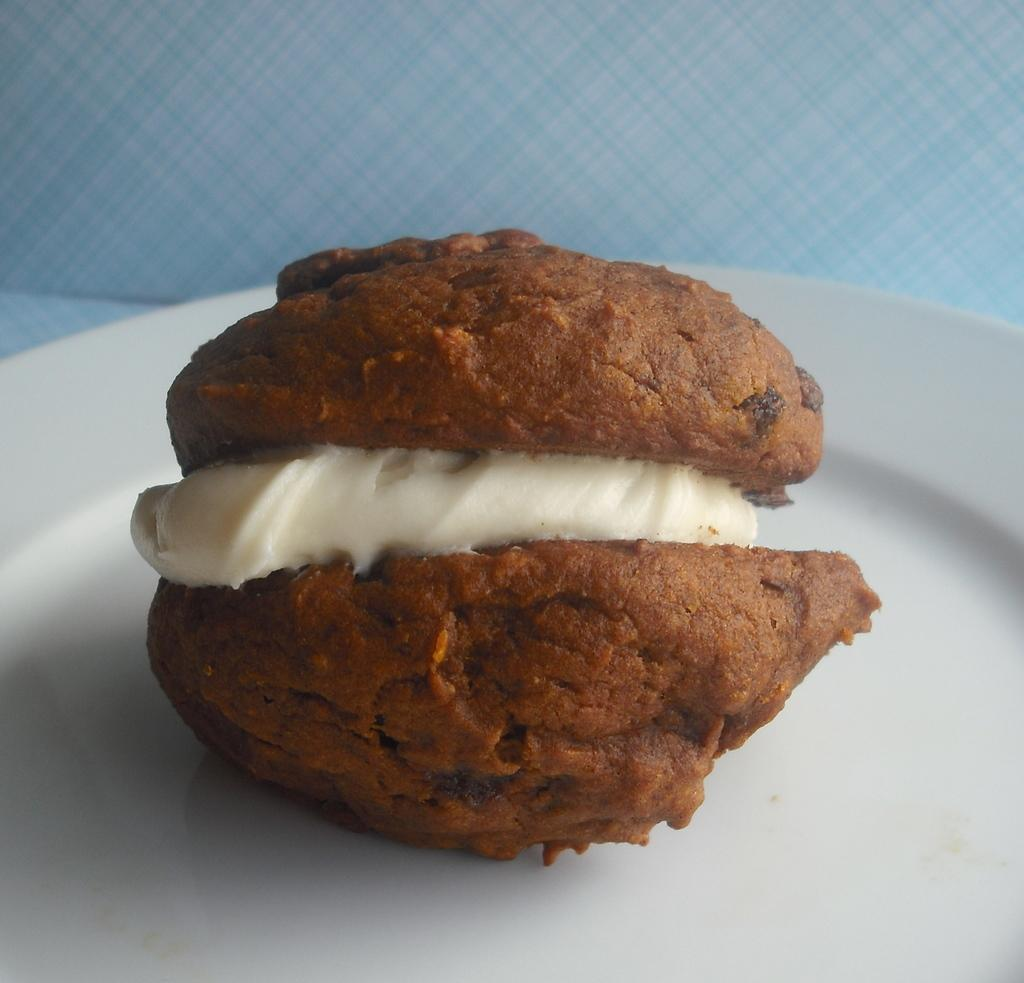What can be seen on the plate in the image? There is a food item on the plate in the image. Can you describe the food item on the plate? Unfortunately, the specific food item cannot be determined from the provided facts. What type of patch is visible on the food item in the image? There is no patch visible on the food item in the image, as the specific type of food item cannot be determined. 